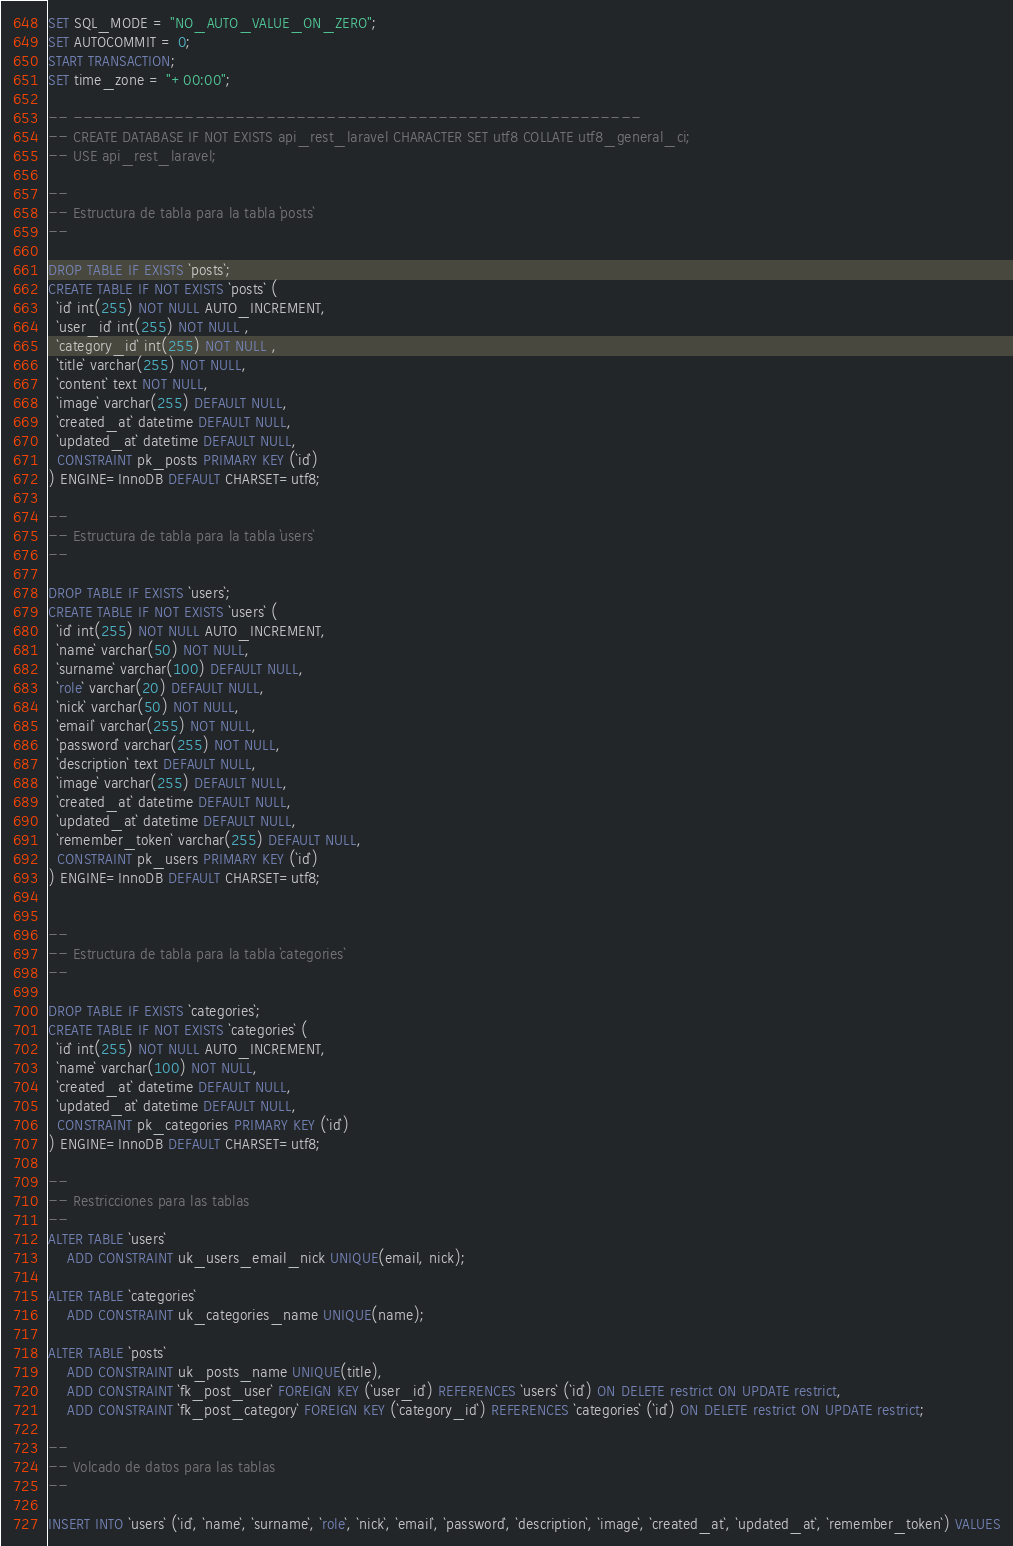Convert code to text. <code><loc_0><loc_0><loc_500><loc_500><_SQL_>SET SQL_MODE = "NO_AUTO_VALUE_ON_ZERO";
SET AUTOCOMMIT = 0;
START TRANSACTION;
SET time_zone = "+00:00";

-- --------------------------------------------------------
-- CREATE DATABASE IF NOT EXISTS api_rest_laravel CHARACTER SET utf8 COLLATE utf8_general_ci;
-- USE api_rest_laravel;

--
-- Estructura de tabla para la tabla `posts`
--

DROP TABLE IF EXISTS `posts`;
CREATE TABLE IF NOT EXISTS `posts` (
  `id` int(255) NOT NULL AUTO_INCREMENT,
  `user_id` int(255) NOT NULL ,
  `category_id` int(255) NOT NULL ,
  `title` varchar(255) NOT NULL,
  `content` text NOT NULL,
  `image` varchar(255) DEFAULT NULL,
  `created_at` datetime DEFAULT NULL,
  `updated_at` datetime DEFAULT NULL,
  CONSTRAINT pk_posts PRIMARY KEY (`id`)
) ENGINE=InnoDB DEFAULT CHARSET=utf8;

--
-- Estructura de tabla para la tabla `users`
--

DROP TABLE IF EXISTS `users`;
CREATE TABLE IF NOT EXISTS `users` (
  `id` int(255) NOT NULL AUTO_INCREMENT,
  `name` varchar(50) NOT NULL,
  `surname` varchar(100) DEFAULT NULL,
  `role` varchar(20) DEFAULT NULL,
  `nick` varchar(50) NOT NULL,
  `email` varchar(255) NOT NULL,
  `password` varchar(255) NOT NULL,
  `description` text DEFAULT NULL,
  `image` varchar(255) DEFAULT NULL,
  `created_at` datetime DEFAULT NULL,
  `updated_at` datetime DEFAULT NULL,
  `remember_token` varchar(255) DEFAULT NULL,
  CONSTRAINT pk_users PRIMARY KEY (`id`)
) ENGINE=InnoDB DEFAULT CHARSET=utf8;


--
-- Estructura de tabla para la tabla `categories`
--

DROP TABLE IF EXISTS `categories`;
CREATE TABLE IF NOT EXISTS `categories` (
  `id` int(255) NOT NULL AUTO_INCREMENT,
  `name` varchar(100) NOT NULL,
  `created_at` datetime DEFAULT NULL,
  `updated_at` datetime DEFAULT NULL,
  CONSTRAINT pk_categories PRIMARY KEY (`id`)
) ENGINE=InnoDB DEFAULT CHARSET=utf8;

--
-- Restricciones para las tablas
--
ALTER TABLE `users`
    ADD CONSTRAINT uk_users_email_nick UNIQUE(email, nick);

ALTER TABLE `categories`
    ADD CONSTRAINT uk_categories_name UNIQUE(name);

ALTER TABLE `posts`
    ADD CONSTRAINT uk_posts_name UNIQUE(title),
    ADD CONSTRAINT `fk_post_user` FOREIGN KEY (`user_id`) REFERENCES `users` (`id`) ON DELETE restrict ON UPDATE restrict,
    ADD CONSTRAINT `fk_post_category` FOREIGN KEY (`category_id`) REFERENCES `categories` (`id`) ON DELETE restrict ON UPDATE restrict;

--
-- Volcado de datos para las tablas
--

INSERT INTO `users` (`id`, `name`, `surname`, `role`, `nick`, `email`, `password`, `description`, `image`, `created_at`, `updated_at`, `remember_token`) VALUES</code> 